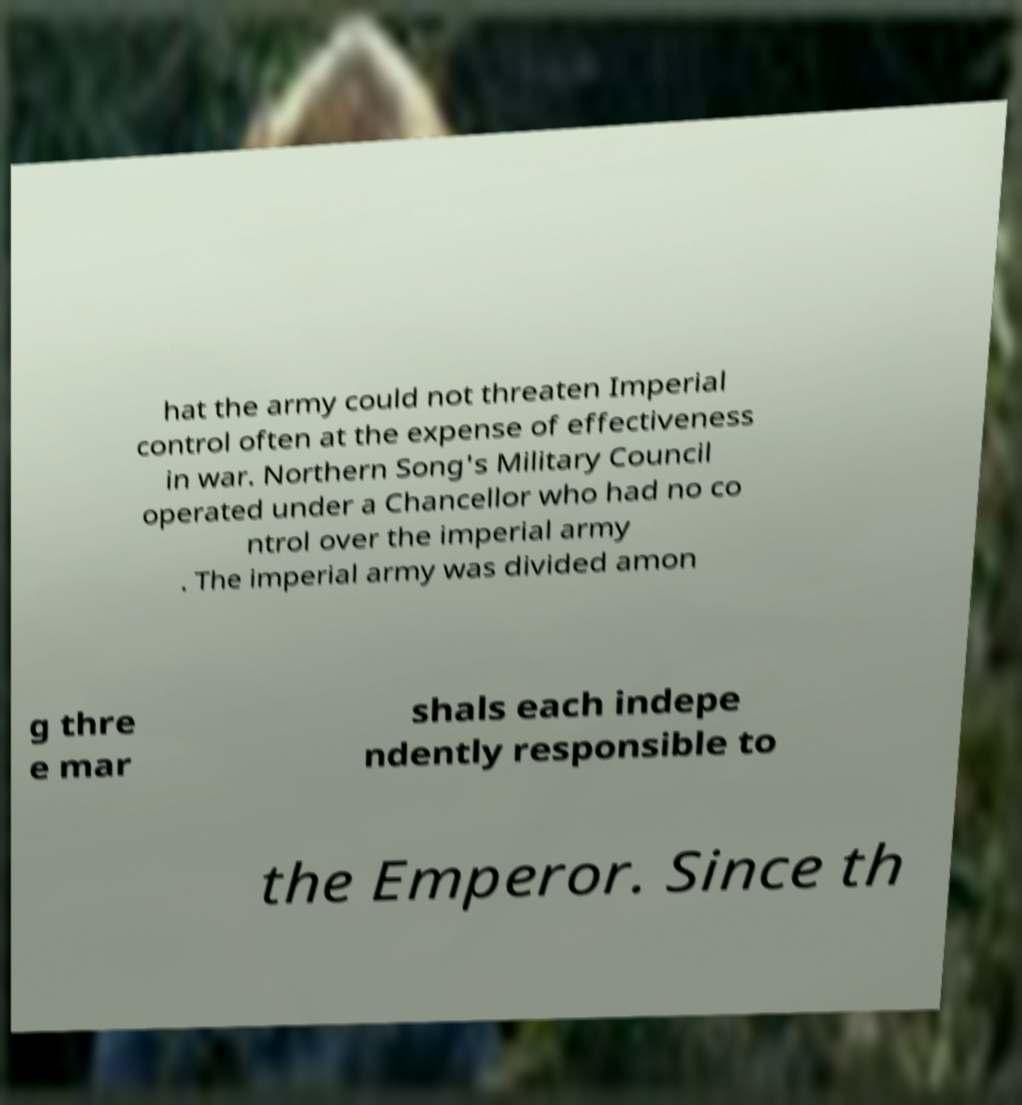There's text embedded in this image that I need extracted. Can you transcribe it verbatim? hat the army could not threaten Imperial control often at the expense of effectiveness in war. Northern Song's Military Council operated under a Chancellor who had no co ntrol over the imperial army . The imperial army was divided amon g thre e mar shals each indepe ndently responsible to the Emperor. Since th 